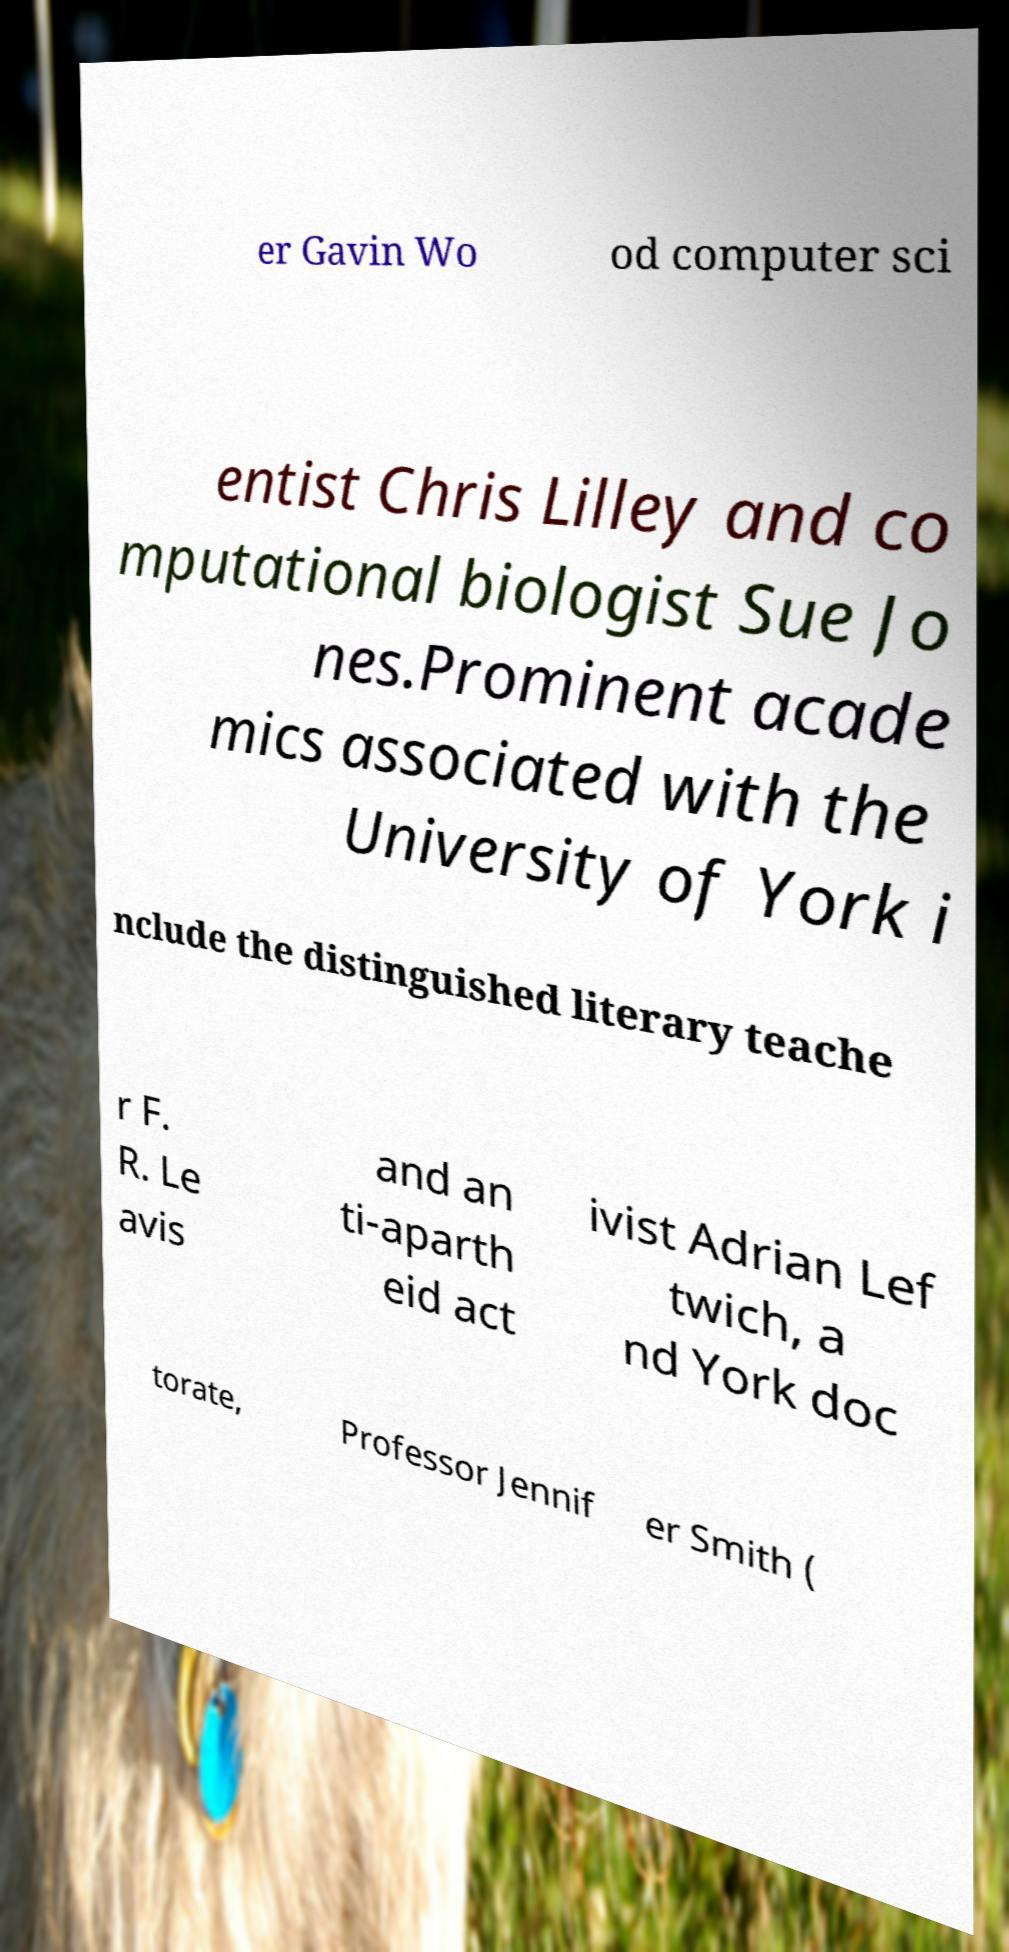Could you extract and type out the text from this image? er Gavin Wo od computer sci entist Chris Lilley and co mputational biologist Sue Jo nes.Prominent acade mics associated with the University of York i nclude the distinguished literary teache r F. R. Le avis and an ti-aparth eid act ivist Adrian Lef twich, a nd York doc torate, Professor Jennif er Smith ( 